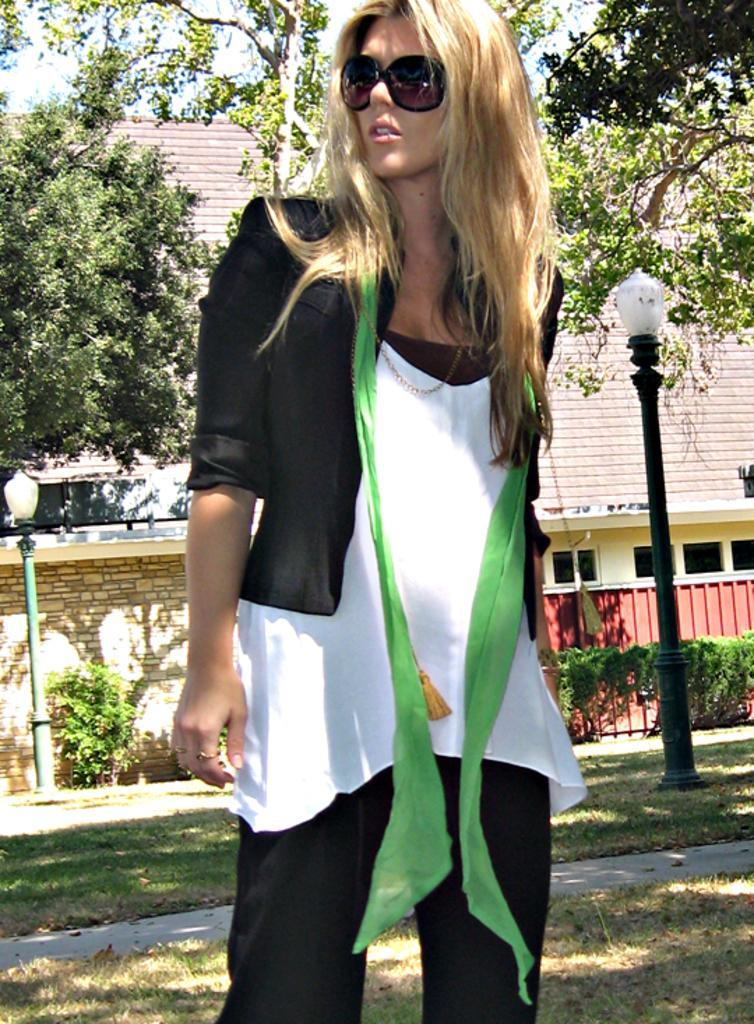Who is present in the image? There is a woman in the image. What is the woman doing in the image? The woman is smiling. What color are the clothes the woman is wearing? The woman is wearing black clothes. What is the color of the background in the image? The background of the image is white in color. What type of sign can be seen on the dock in the image? There is no dock or sign present in the image; it features a woman wearing black clothes with a white background. What is the condition of the woman's teeth in the image? The condition of the woman's teeth cannot be determined from the image, as it only shows her smiling and wearing black clothes against a white background. 